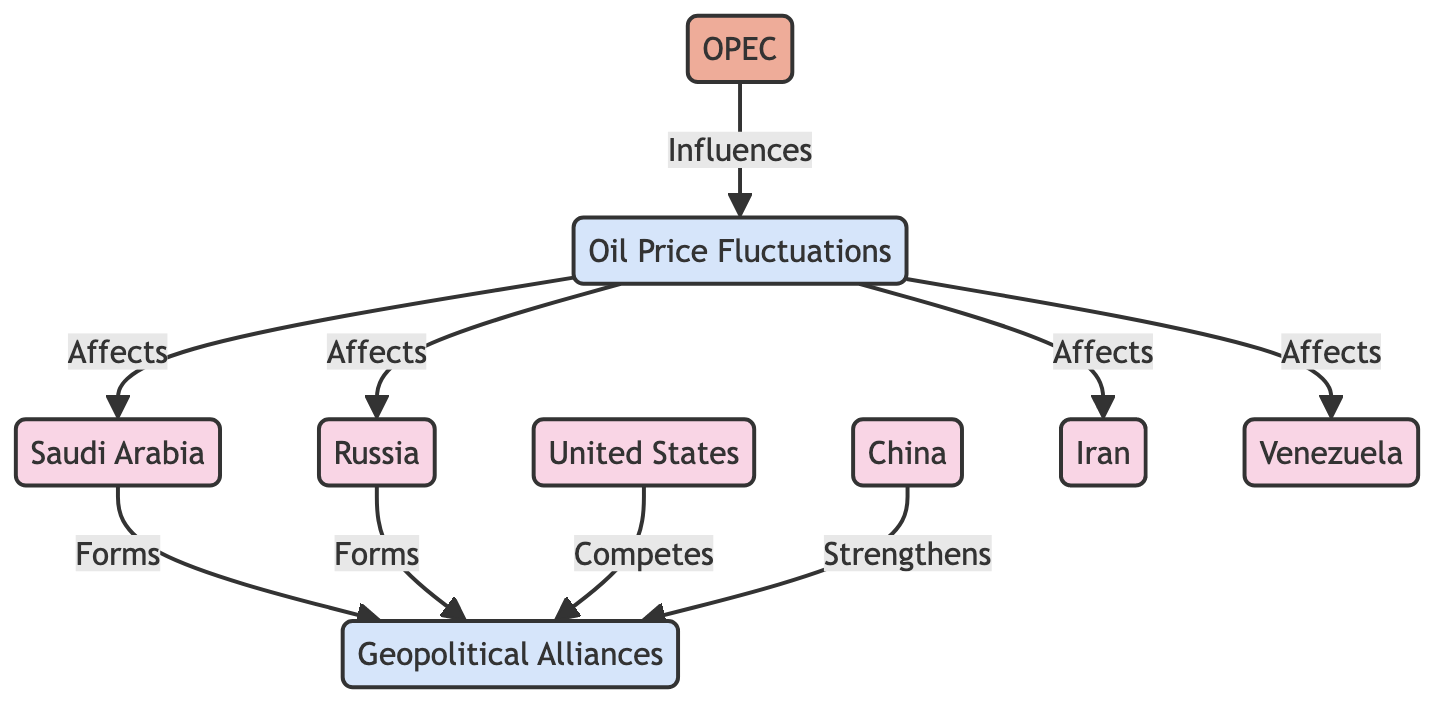What is the total number of nodes in the diagram? The diagram has a total of 9 nodes: OPEC, Russia, Saudi Arabia, United States, China, Iran, Venezuela, Oil Price Fluctuations, and Geopolitical Alliances.
Answer: 9 Which organization influences oil price fluctuations? OPEC is the organization that directly influences oil price fluctuations as shown by the arrow from OPEC to Price Fluctuation indicating an influential relationship.
Answer: OPEC How many countries are affected by oil price fluctuations? The diagram shows that there are four countries that are affected by oil price fluctuations: Saudi Arabia, Russia, Iran, and Venezuela, as indicated by the arrows pointing from Price Fluctuation to each of these countries.
Answer: 4 What kind of relationship does Saudi Arabia have with geopolitical alliances? The diagram indicates that Saudi Arabia forms geopolitical alliances, as shown by the directed edge from Saudi Arabia to Geopolitical Alliances labeled "Forms."
Answer: Forms Which country competes with others in forming geopolitical alliances? The directed edge from United States to Geopolitical Alliances indicates that the United States competes in forming geopolitical alliances.
Answer: Competes Which country strengthens geopolitical alliances? The diagram indicates that China strengthens geopolitical alliances, as shown by the edge pointing from China to Geopolitical Alliances labeled "Strengthens."
Answer: Strengthens What is the relationship between price fluctuations and Russia? The diagram indicates that price fluctuations affect Russia, as shown by the directed edge from Price Fluctuation to Russia labeled "Affects."
Answer: Affects How many edges connect the nodes in the diagram? The diagram has a total of 8 directed edges connecting the nodes, indicating relationships between the countries and concepts presented.
Answer: 8 What is the role of oil price fluctuations in geopolitical alliances? Oil price fluctuations impact multiple countries, which in turn engage in forming or competing in geopolitical alliances, signifying an indirect but influential role.
Answer: Influential 